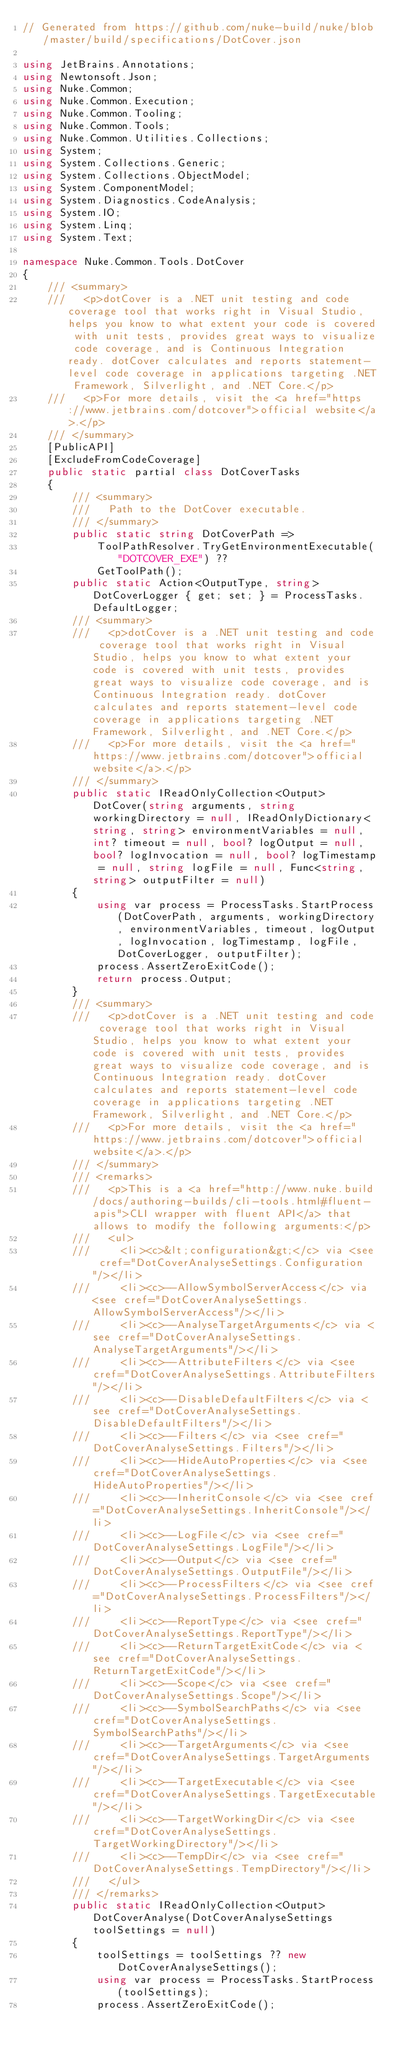<code> <loc_0><loc_0><loc_500><loc_500><_C#_>// Generated from https://github.com/nuke-build/nuke/blob/master/build/specifications/DotCover.json

using JetBrains.Annotations;
using Newtonsoft.Json;
using Nuke.Common;
using Nuke.Common.Execution;
using Nuke.Common.Tooling;
using Nuke.Common.Tools;
using Nuke.Common.Utilities.Collections;
using System;
using System.Collections.Generic;
using System.Collections.ObjectModel;
using System.ComponentModel;
using System.Diagnostics.CodeAnalysis;
using System.IO;
using System.Linq;
using System.Text;

namespace Nuke.Common.Tools.DotCover
{
    /// <summary>
    ///   <p>dotCover is a .NET unit testing and code coverage tool that works right in Visual Studio, helps you know to what extent your code is covered with unit tests, provides great ways to visualize code coverage, and is Continuous Integration ready. dotCover calculates and reports statement-level code coverage in applications targeting .NET Framework, Silverlight, and .NET Core.</p>
    ///   <p>For more details, visit the <a href="https://www.jetbrains.com/dotcover">official website</a>.</p>
    /// </summary>
    [PublicAPI]
    [ExcludeFromCodeCoverage]
    public static partial class DotCoverTasks
    {
        /// <summary>
        ///   Path to the DotCover executable.
        /// </summary>
        public static string DotCoverPath =>
            ToolPathResolver.TryGetEnvironmentExecutable("DOTCOVER_EXE") ??
            GetToolPath();
        public static Action<OutputType, string> DotCoverLogger { get; set; } = ProcessTasks.DefaultLogger;
        /// <summary>
        ///   <p>dotCover is a .NET unit testing and code coverage tool that works right in Visual Studio, helps you know to what extent your code is covered with unit tests, provides great ways to visualize code coverage, and is Continuous Integration ready. dotCover calculates and reports statement-level code coverage in applications targeting .NET Framework, Silverlight, and .NET Core.</p>
        ///   <p>For more details, visit the <a href="https://www.jetbrains.com/dotcover">official website</a>.</p>
        /// </summary>
        public static IReadOnlyCollection<Output> DotCover(string arguments, string workingDirectory = null, IReadOnlyDictionary<string, string> environmentVariables = null, int? timeout = null, bool? logOutput = null, bool? logInvocation = null, bool? logTimestamp = null, string logFile = null, Func<string, string> outputFilter = null)
        {
            using var process = ProcessTasks.StartProcess(DotCoverPath, arguments, workingDirectory, environmentVariables, timeout, logOutput, logInvocation, logTimestamp, logFile, DotCoverLogger, outputFilter);
            process.AssertZeroExitCode();
            return process.Output;
        }
        /// <summary>
        ///   <p>dotCover is a .NET unit testing and code coverage tool that works right in Visual Studio, helps you know to what extent your code is covered with unit tests, provides great ways to visualize code coverage, and is Continuous Integration ready. dotCover calculates and reports statement-level code coverage in applications targeting .NET Framework, Silverlight, and .NET Core.</p>
        ///   <p>For more details, visit the <a href="https://www.jetbrains.com/dotcover">official website</a>.</p>
        /// </summary>
        /// <remarks>
        ///   <p>This is a <a href="http://www.nuke.build/docs/authoring-builds/cli-tools.html#fluent-apis">CLI wrapper with fluent API</a> that allows to modify the following arguments:</p>
        ///   <ul>
        ///     <li><c>&lt;configuration&gt;</c> via <see cref="DotCoverAnalyseSettings.Configuration"/></li>
        ///     <li><c>--AllowSymbolServerAccess</c> via <see cref="DotCoverAnalyseSettings.AllowSymbolServerAccess"/></li>
        ///     <li><c>--AnalyseTargetArguments</c> via <see cref="DotCoverAnalyseSettings.AnalyseTargetArguments"/></li>
        ///     <li><c>--AttributeFilters</c> via <see cref="DotCoverAnalyseSettings.AttributeFilters"/></li>
        ///     <li><c>--DisableDefaultFilters</c> via <see cref="DotCoverAnalyseSettings.DisableDefaultFilters"/></li>
        ///     <li><c>--Filters</c> via <see cref="DotCoverAnalyseSettings.Filters"/></li>
        ///     <li><c>--HideAutoProperties</c> via <see cref="DotCoverAnalyseSettings.HideAutoProperties"/></li>
        ///     <li><c>--InheritConsole</c> via <see cref="DotCoverAnalyseSettings.InheritConsole"/></li>
        ///     <li><c>--LogFile</c> via <see cref="DotCoverAnalyseSettings.LogFile"/></li>
        ///     <li><c>--Output</c> via <see cref="DotCoverAnalyseSettings.OutputFile"/></li>
        ///     <li><c>--ProcessFilters</c> via <see cref="DotCoverAnalyseSettings.ProcessFilters"/></li>
        ///     <li><c>--ReportType</c> via <see cref="DotCoverAnalyseSettings.ReportType"/></li>
        ///     <li><c>--ReturnTargetExitCode</c> via <see cref="DotCoverAnalyseSettings.ReturnTargetExitCode"/></li>
        ///     <li><c>--Scope</c> via <see cref="DotCoverAnalyseSettings.Scope"/></li>
        ///     <li><c>--SymbolSearchPaths</c> via <see cref="DotCoverAnalyseSettings.SymbolSearchPaths"/></li>
        ///     <li><c>--TargetArguments</c> via <see cref="DotCoverAnalyseSettings.TargetArguments"/></li>
        ///     <li><c>--TargetExecutable</c> via <see cref="DotCoverAnalyseSettings.TargetExecutable"/></li>
        ///     <li><c>--TargetWorkingDir</c> via <see cref="DotCoverAnalyseSettings.TargetWorkingDirectory"/></li>
        ///     <li><c>--TempDir</c> via <see cref="DotCoverAnalyseSettings.TempDirectory"/></li>
        ///   </ul>
        /// </remarks>
        public static IReadOnlyCollection<Output> DotCoverAnalyse(DotCoverAnalyseSettings toolSettings = null)
        {
            toolSettings = toolSettings ?? new DotCoverAnalyseSettings();
            using var process = ProcessTasks.StartProcess(toolSettings);
            process.AssertZeroExitCode();</code> 